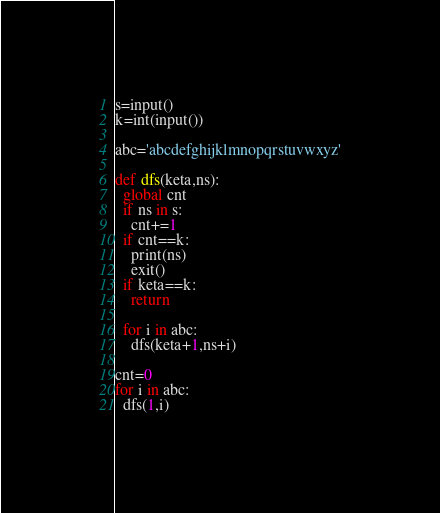Convert code to text. <code><loc_0><loc_0><loc_500><loc_500><_Python_>s=input()
k=int(input())

abc='abcdefghijklmnopqrstuvwxyz'

def dfs(keta,ns):
  global cnt
  if ns in s:
    cnt+=1
  if cnt==k:
    print(ns)
    exit()
  if keta==k:
    return

  for i in abc:
    dfs(keta+1,ns+i)

cnt=0
for i in abc:
  dfs(1,i)</code> 